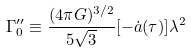Convert formula to latex. <formula><loc_0><loc_0><loc_500><loc_500>\Gamma _ { 0 } ^ { \prime \prime } \equiv \frac { ( 4 \pi G ) ^ { 3 / 2 } } { 5 \sqrt { 3 } } [ - \dot { a } ( \tau ) ] \lambda ^ { 2 }</formula> 